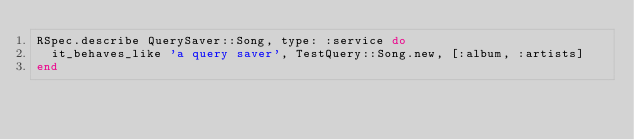Convert code to text. <code><loc_0><loc_0><loc_500><loc_500><_Ruby_>RSpec.describe QuerySaver::Song, type: :service do
  it_behaves_like 'a query saver', TestQuery::Song.new, [:album, :artists]
end
</code> 